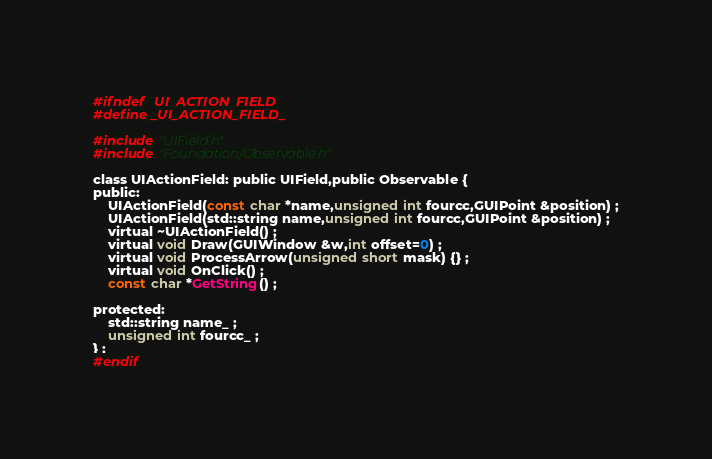<code> <loc_0><loc_0><loc_500><loc_500><_C_>#ifndef _UI_ACTION_FIELD_
#define _UI_ACTION_FIELD_

#include "UIField.h"
#include "Foundation/Observable.h"

class UIActionField: public UIField,public Observable {
public:
	UIActionField(const char *name,unsigned int fourcc,GUIPoint &position) ;
	UIActionField(std::string name,unsigned int fourcc,GUIPoint &position) ;
	virtual ~UIActionField() ;
	virtual void Draw(GUIWindow &w,int offset=0) ;
	virtual void ProcessArrow(unsigned short mask) {} ;
	virtual void OnClick() ;
	const char *GetString() ;

protected:
	std::string name_ ;
	unsigned int fourcc_ ;
} ;
#endif
</code> 